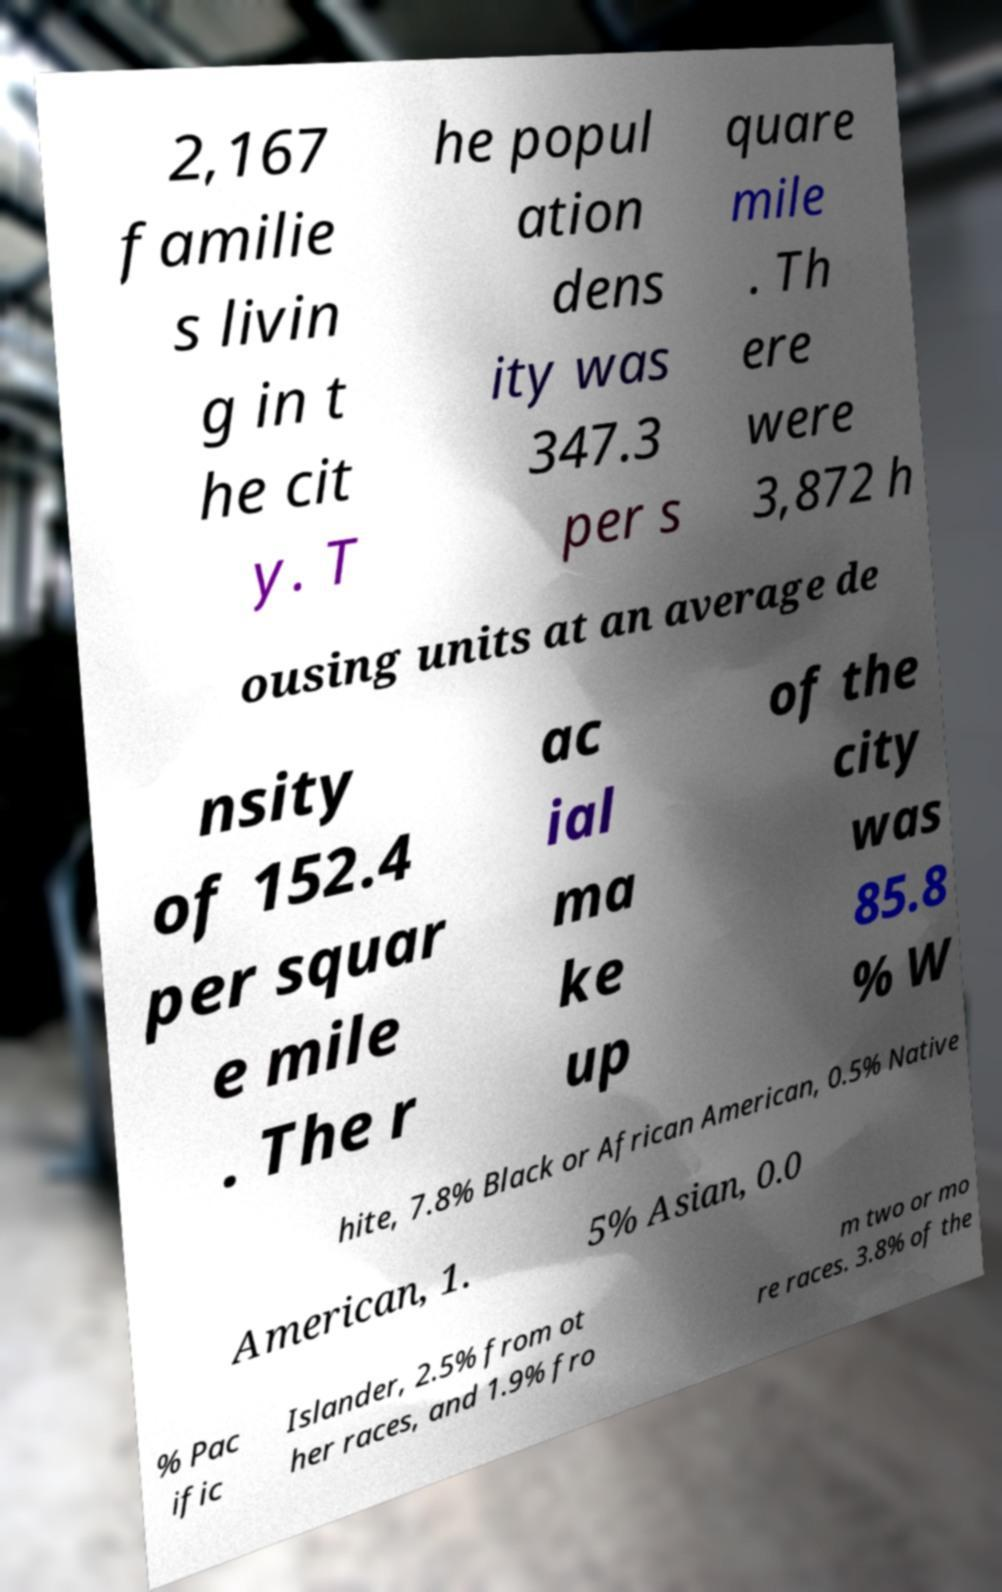What messages or text are displayed in this image? I need them in a readable, typed format. 2,167 familie s livin g in t he cit y. T he popul ation dens ity was 347.3 per s quare mile . Th ere were 3,872 h ousing units at an average de nsity of 152.4 per squar e mile . The r ac ial ma ke up of the city was 85.8 % W hite, 7.8% Black or African American, 0.5% Native American, 1. 5% Asian, 0.0 % Pac ific Islander, 2.5% from ot her races, and 1.9% fro m two or mo re races. 3.8% of the 